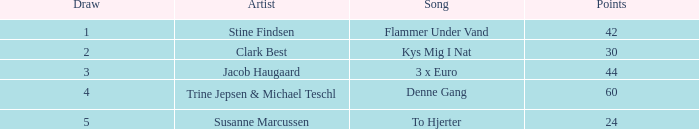What is the least draw when the artist is stine findsen and the points are more than 42? None. 